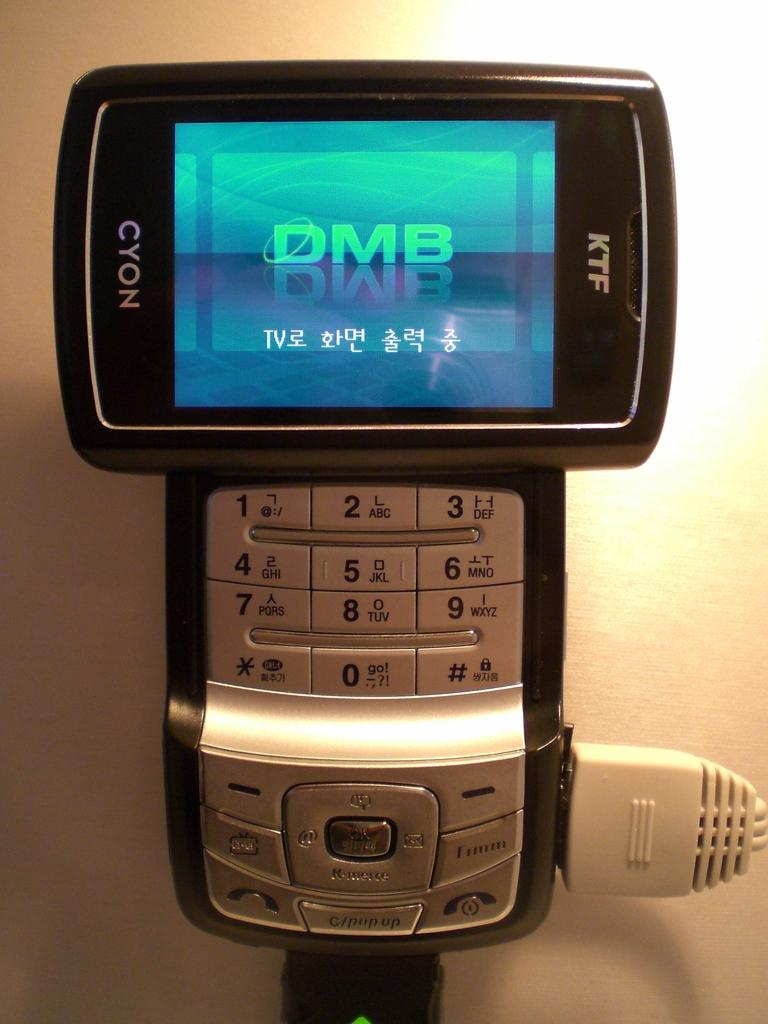<image>
Present a compact description of the photo's key features. A KTF Cyon phone that is showing DMB on the screen 